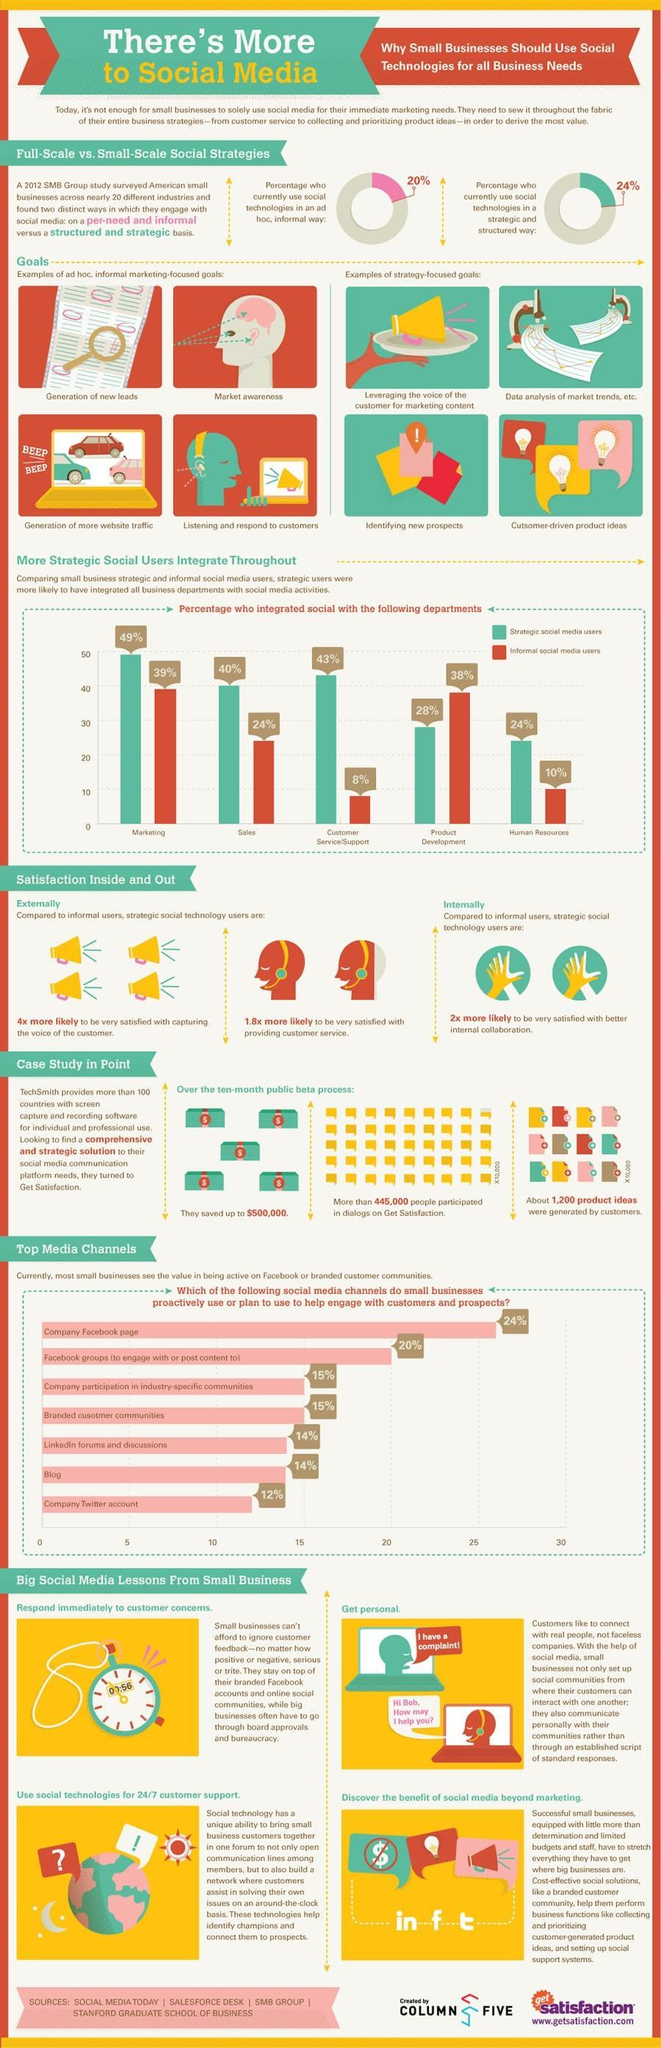What is the time mentioned in the clock?
Answer the question with a short phrase. 00:56 How many strategy-focused goals mentioned in this infographic? 4 What percentage of small businesses together use the company's Facebook page and blog to help engage with customers and prospects? 38% What percentage of people are not using social technologies in a strategic and structured way? 76% What percentage of people are not using social technologies in an ad-hoc and informal way? 80% How many ad-hoc, informal marketing-focused goals mentioned in this infographic? 4 What percentage of strategic and informal social media users are in marketing, taken together? 88% What percentage of strategic and informal social media users are in sales, taken together? 64% What percentage of small businesses together use the company's Facebook page and Twitter account to help engage with customers and prospects? 36% What percentage of strategic and informal social media users are in product development, taken together? 66% 